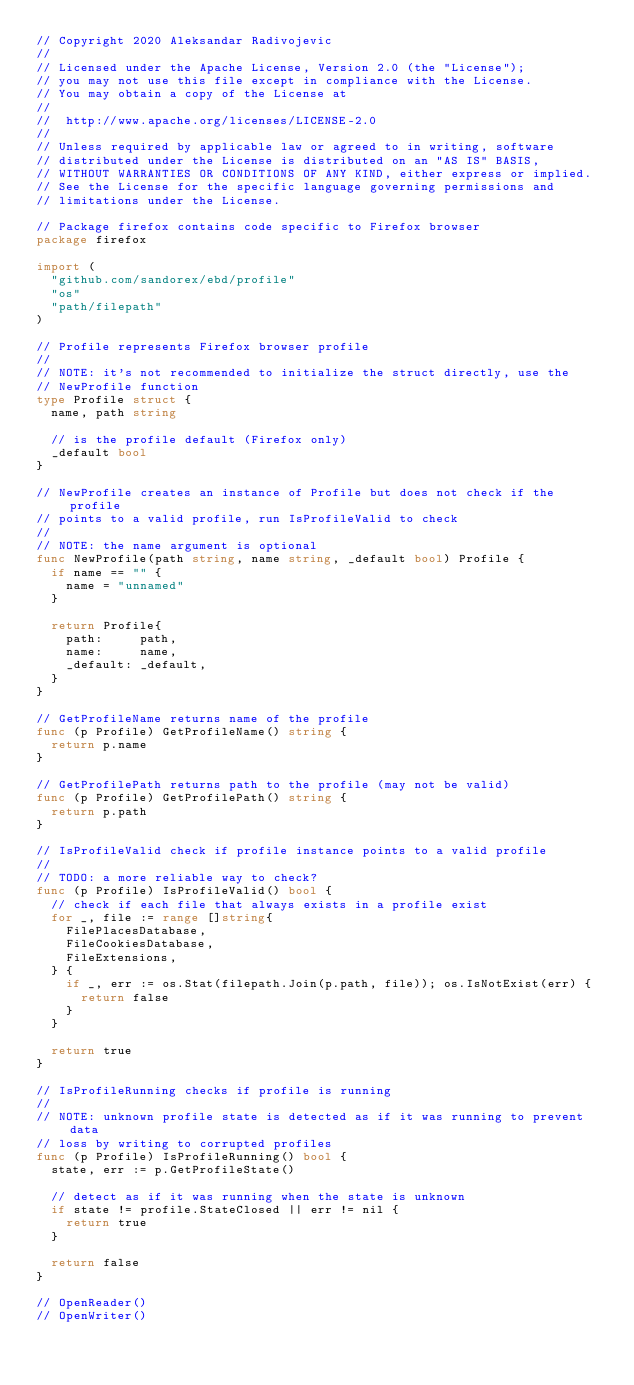<code> <loc_0><loc_0><loc_500><loc_500><_Go_>// Copyright 2020 Aleksandar Radivojevic
//
// Licensed under the Apache License, Version 2.0 (the "License");
// you may not use this file except in compliance with the License.
// You may obtain a copy of the License at
//
// 	http://www.apache.org/licenses/LICENSE-2.0
//
// Unless required by applicable law or agreed to in writing, software
// distributed under the License is distributed on an "AS IS" BASIS,
// WITHOUT WARRANTIES OR CONDITIONS OF ANY KIND, either express or implied.
// See the License for the specific language governing permissions and
// limitations under the License.

// Package firefox contains code specific to Firefox browser
package firefox

import (
	"github.com/sandorex/ebd/profile"
	"os"
	"path/filepath"
)

// Profile represents Firefox browser profile
//
// NOTE: it's not recommended to initialize the struct directly, use the
// NewProfile function
type Profile struct {
	name, path string

	// is the profile default (Firefox only)
	_default bool
}

// NewProfile creates an instance of Profile but does not check if the profile
// points to a valid profile, run IsProfileValid to check
//
// NOTE: the name argument is optional
func NewProfile(path string, name string, _default bool) Profile {
	if name == "" {
		name = "unnamed"
	}

	return Profile{
		path:     path,
		name:     name,
		_default: _default,
	}
}

// GetProfileName returns name of the profile
func (p Profile) GetProfileName() string {
	return p.name
}

// GetProfilePath returns path to the profile (may not be valid)
func (p Profile) GetProfilePath() string {
	return p.path
}

// IsProfileValid check if profile instance points to a valid profile
//
// TODO: a more reliable way to check?
func (p Profile) IsProfileValid() bool {
	// check if each file that always exists in a profile exist
	for _, file := range []string{
		FilePlacesDatabase,
		FileCookiesDatabase,
		FileExtensions,
	} {
		if _, err := os.Stat(filepath.Join(p.path, file)); os.IsNotExist(err) {
			return false
		}
	}

	return true
}

// IsProfileRunning checks if profile is running
//
// NOTE: unknown profile state is detected as if it was running to prevent data
// loss by writing to corrupted profiles
func (p Profile) IsProfileRunning() bool {
	state, err := p.GetProfileState()

	// detect as if it was running when the state is unknown
	if state != profile.StateClosed || err != nil {
		return true
	}

	return false
}

// OpenReader()
// OpenWriter()
</code> 